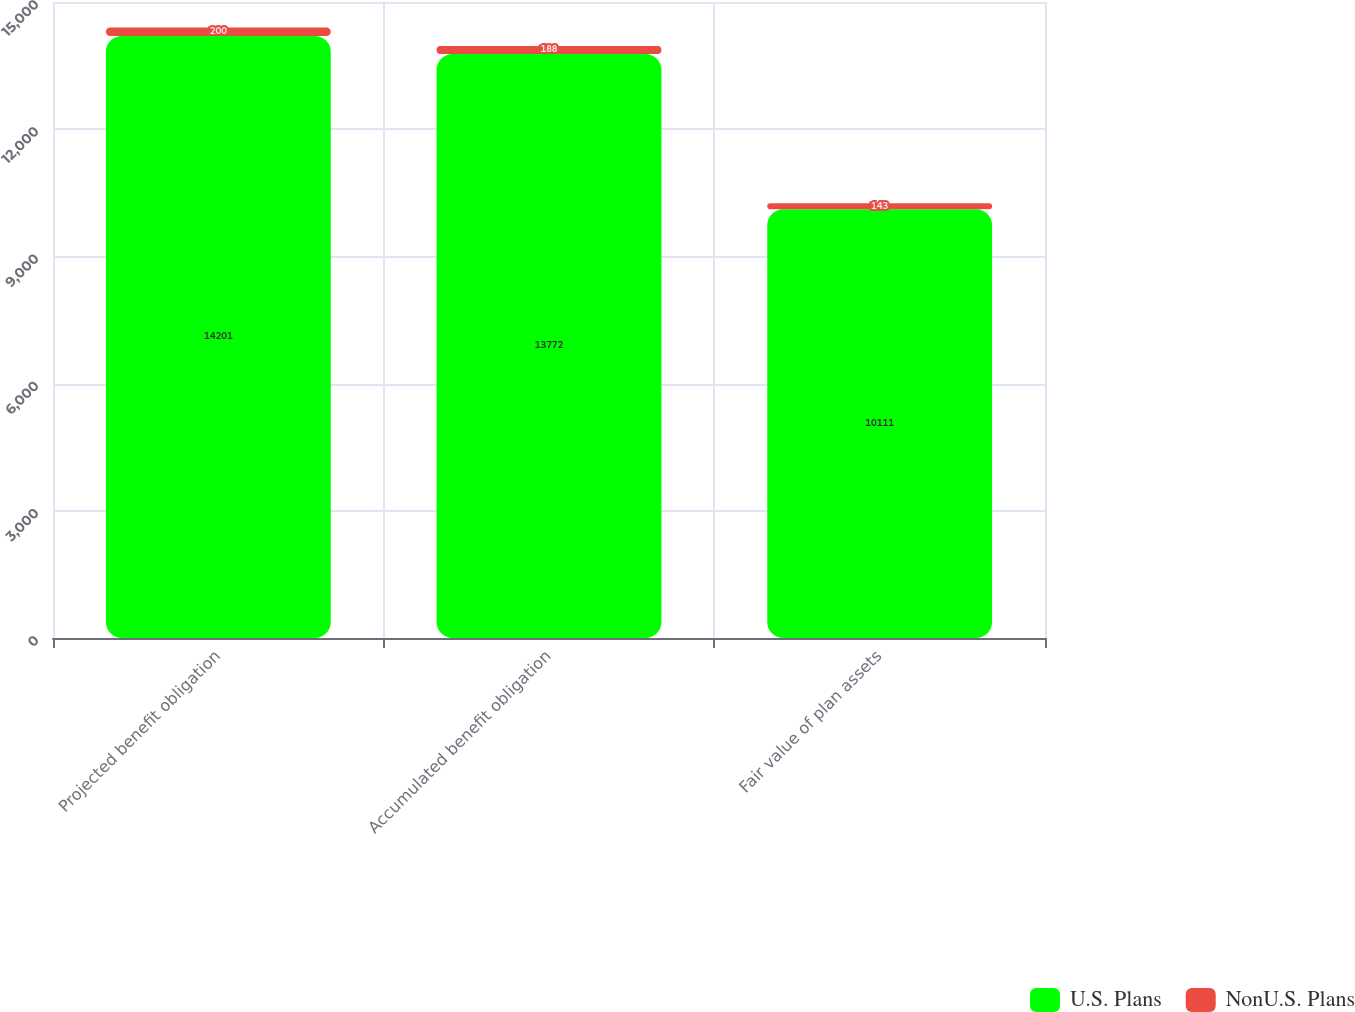Convert chart. <chart><loc_0><loc_0><loc_500><loc_500><stacked_bar_chart><ecel><fcel>Projected benefit obligation<fcel>Accumulated benefit obligation<fcel>Fair value of plan assets<nl><fcel>U.S. Plans<fcel>14201<fcel>13772<fcel>10111<nl><fcel>NonU.S. Plans<fcel>200<fcel>188<fcel>143<nl></chart> 